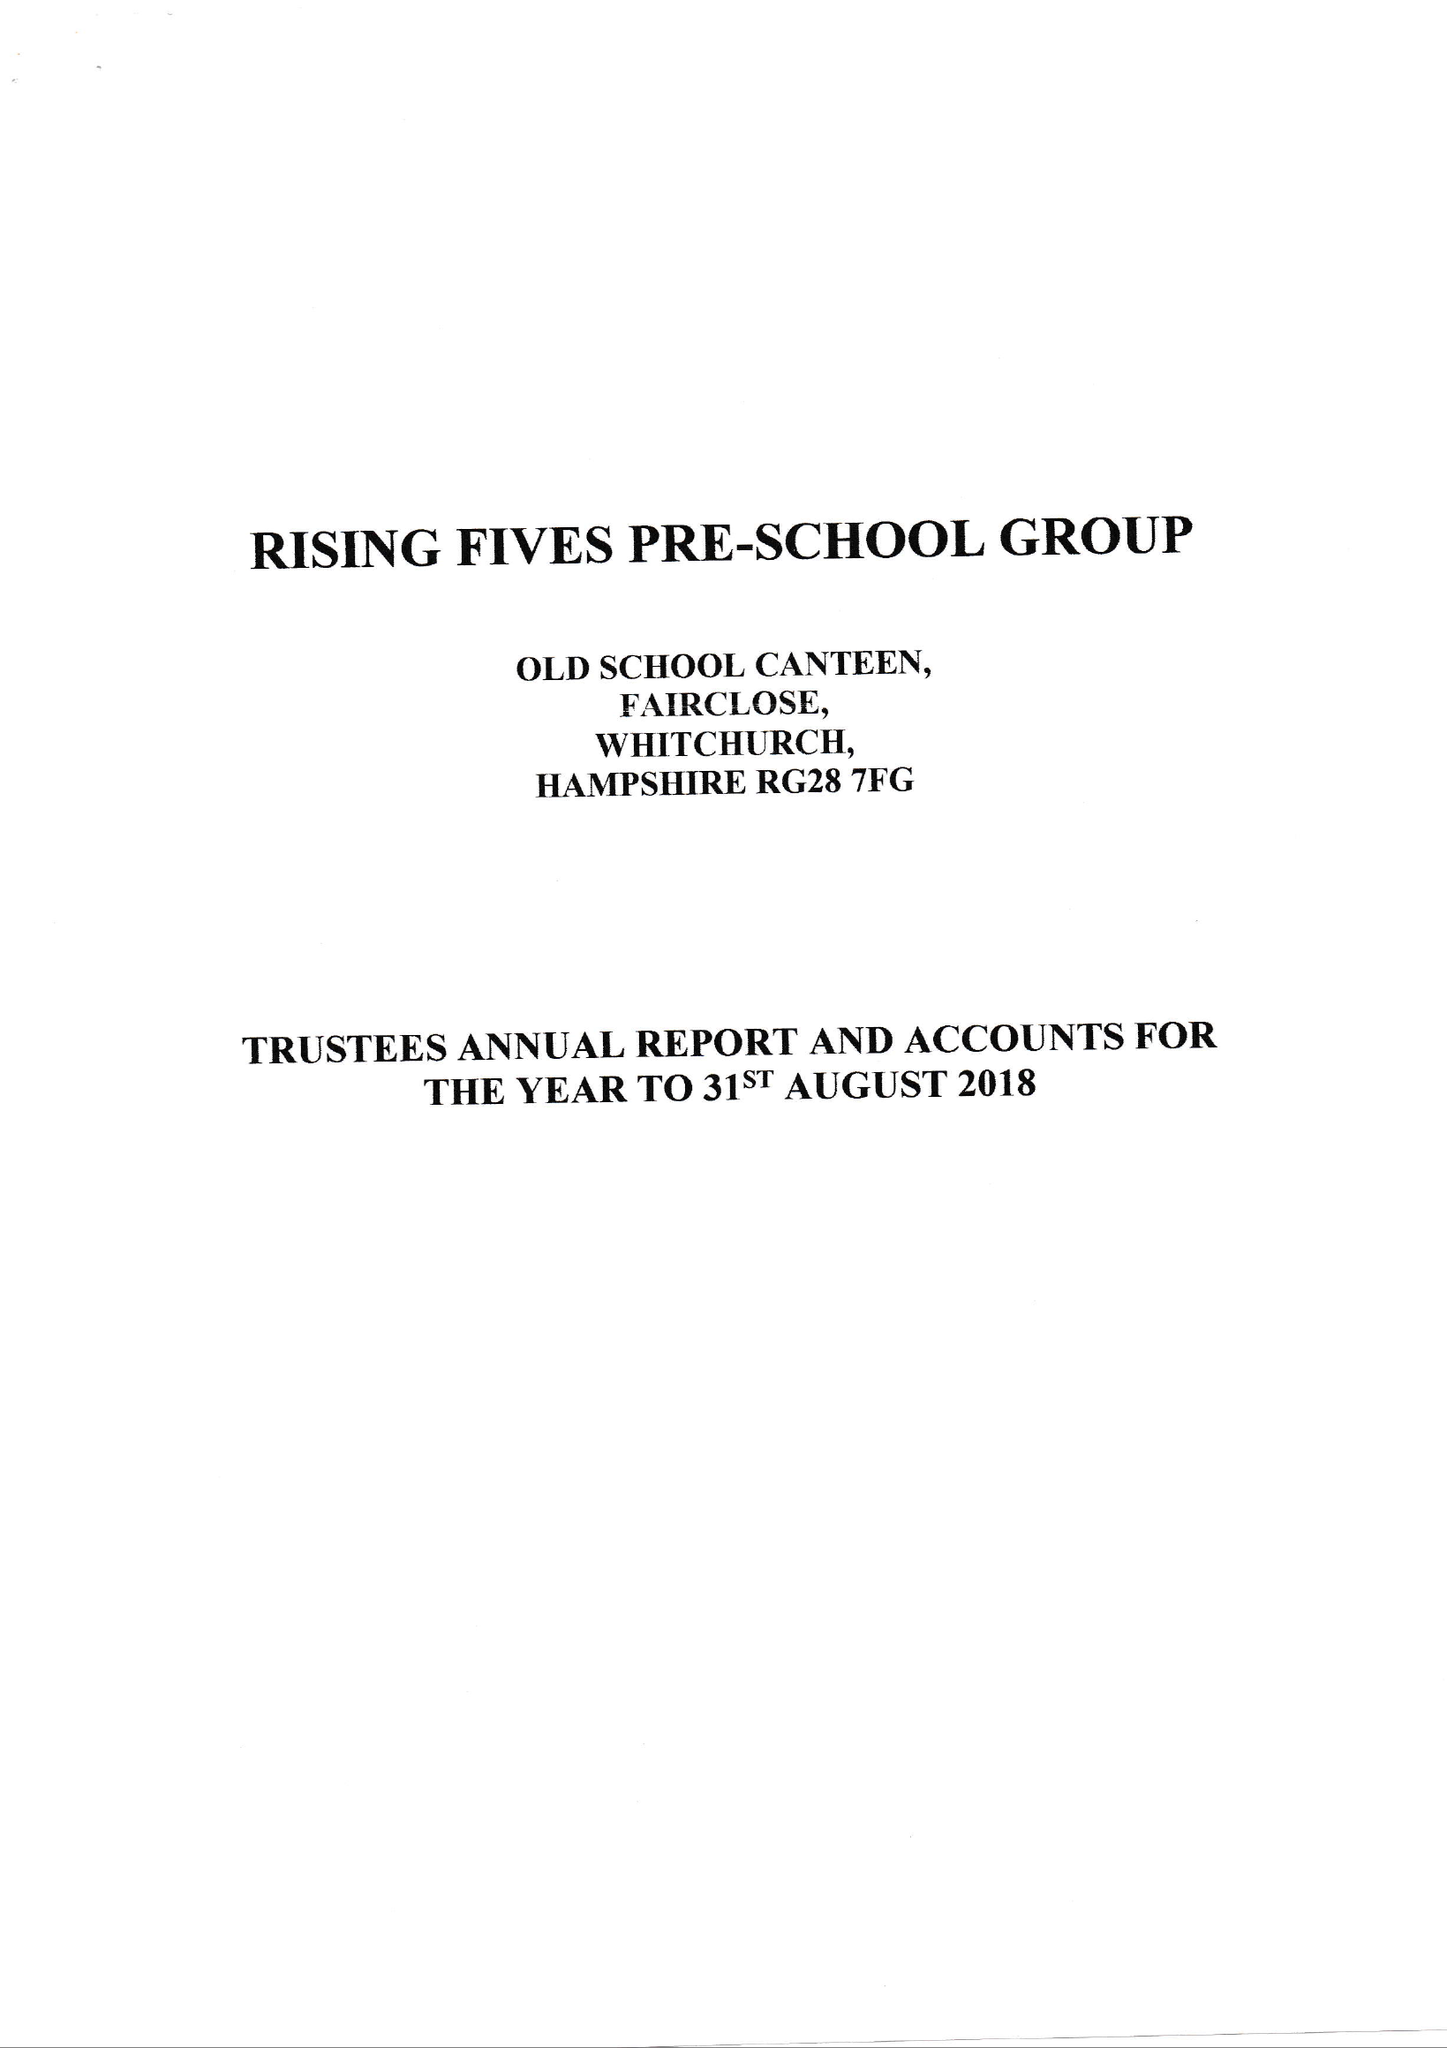What is the value for the address__street_line?
Answer the question using a single word or phrase. WELLS LANE 